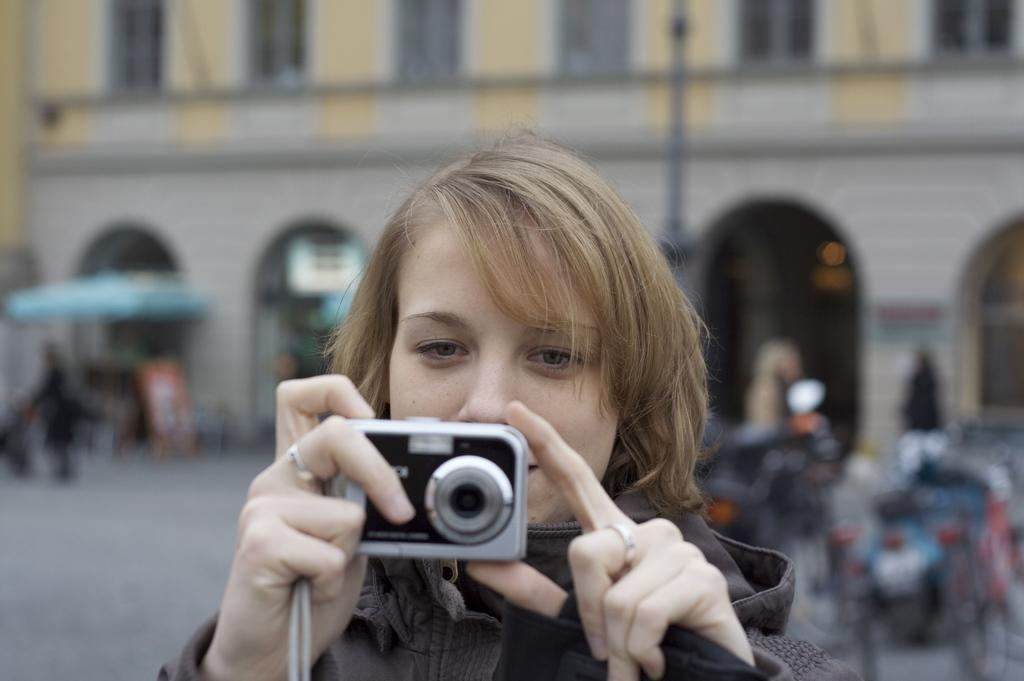Who is the main subject in the image? There is a woman in the image. What is the woman holding in the image? The woman is holding a camera. What type of clothing is the woman wearing? The woman is wearing a jacket. Can you describe any accessories the woman is wearing? The woman has a ring on her finger. What can be seen in the background of the image? There is a building in the background of the image. What type of boot is the woman wearing in the image? There is no boot visible in the image; the woman is wearing a jacket. What type of shirt is the woman wearing under her jacket in the image? The provided facts do not mention a shirt; the woman is only described as wearing a jacket. 